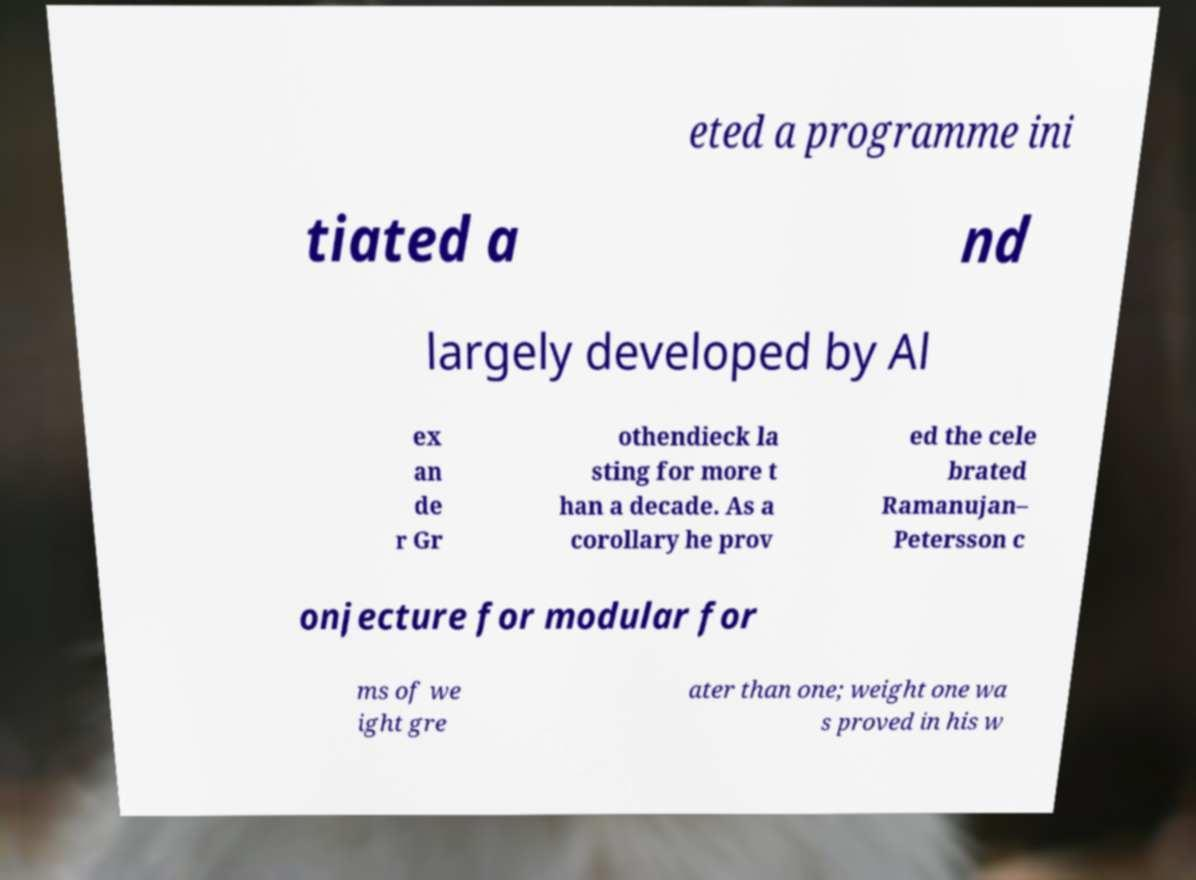Please identify and transcribe the text found in this image. eted a programme ini tiated a nd largely developed by Al ex an de r Gr othendieck la sting for more t han a decade. As a corollary he prov ed the cele brated Ramanujan– Petersson c onjecture for modular for ms of we ight gre ater than one; weight one wa s proved in his w 